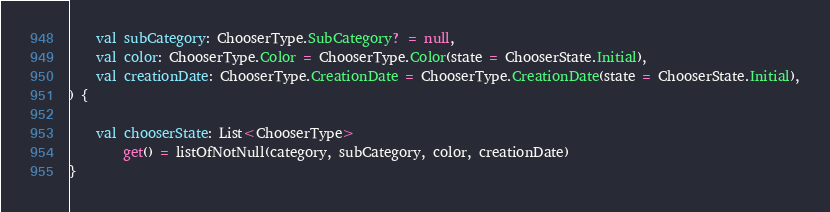Convert code to text. <code><loc_0><loc_0><loc_500><loc_500><_Kotlin_>    val subCategory: ChooserType.SubCategory? = null,
    val color: ChooserType.Color = ChooserType.Color(state = ChooserState.Initial),
    val creationDate: ChooserType.CreationDate = ChooserType.CreationDate(state = ChooserState.Initial),
) {

    val chooserState: List<ChooserType>
        get() = listOfNotNull(category, subCategory, color, creationDate)
}</code> 